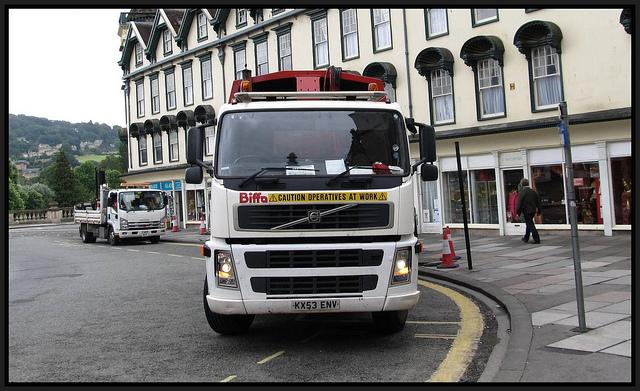Are there any pedestrians walking in the street?
Quick response, please. No. Could this be in Great Britain?
Keep it brief. Yes. Are there safety cones in this picture?
Write a very short answer. Yes. 